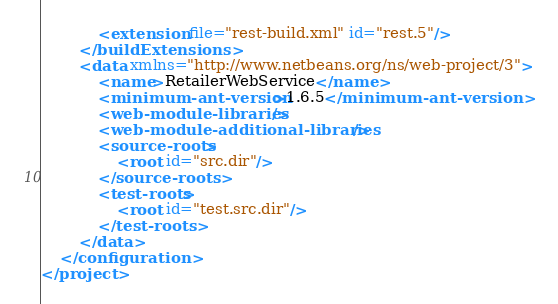Convert code to text. <code><loc_0><loc_0><loc_500><loc_500><_XML_>            <extension file="rest-build.xml" id="rest.5"/>
        </buildExtensions>
        <data xmlns="http://www.netbeans.org/ns/web-project/3">
            <name>RetailerWebService</name>
            <minimum-ant-version>1.6.5</minimum-ant-version>
            <web-module-libraries/>
            <web-module-additional-libraries/>
            <source-roots>
                <root id="src.dir"/>
            </source-roots>
            <test-roots>
                <root id="test.src.dir"/>
            </test-roots>
        </data>
    </configuration>
</project>
</code> 